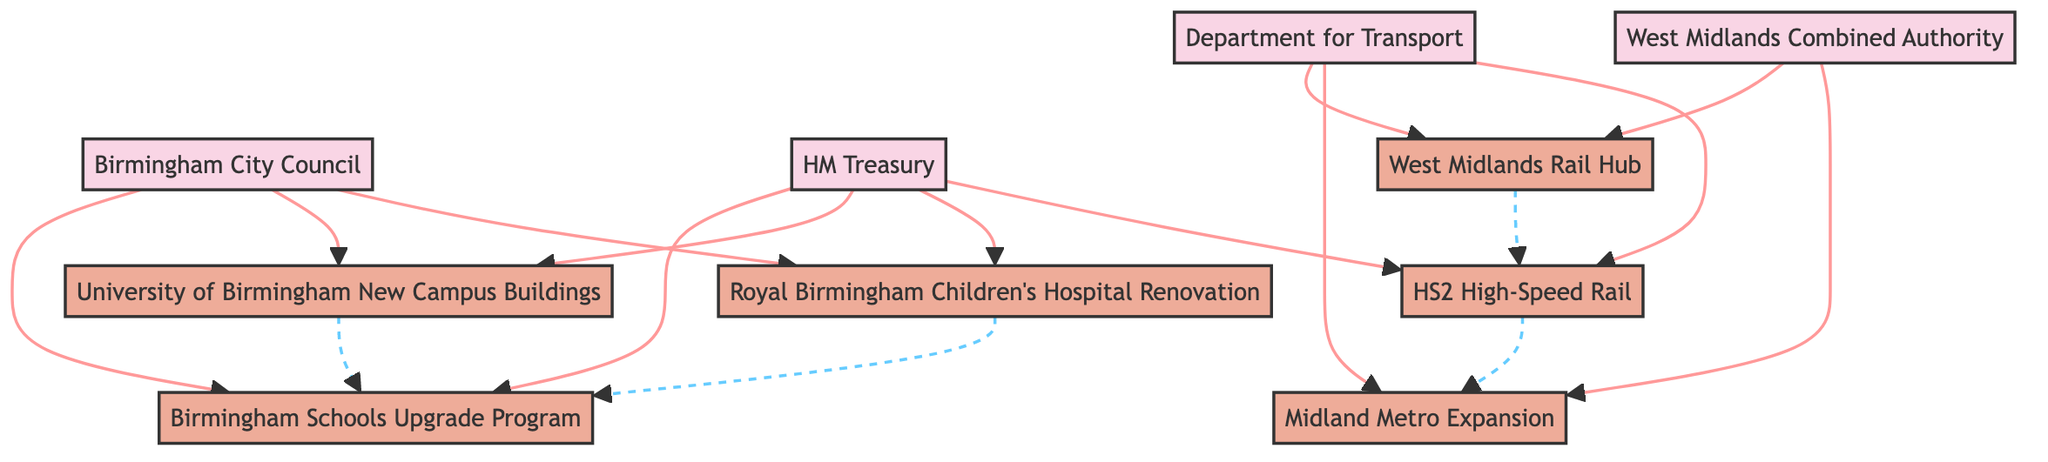What are the transportation projects in the diagram? The diagram lists three transportation projects: HS2 High-Speed Rail, Midland Metro Expansion, and West Midlands Rail Hub. Each of these projects is labeled as a transportation project in the diagram.
Answer: HS2 High-Speed Rail, Midland Metro Expansion, West Midlands Rail Hub How many funding sources are represented? The diagram includes four funding sources: Birmingham City Council, Department for Transport, West Midlands Combined Authority, and HM Treasury. Counting the unique funding sources gives us a total of four.
Answer: 4 What interdependency involves education projects? The interdependency involving education projects is between University of Birmingham New Campus Buildings and Birmingham Schools Upgrade Program. This relationship shows how the improvement in educational infrastructure contributes to skills development.
Answer: University of Birmingham New Campus Buildings and Birmingham Schools Upgrade Program Which project is funded by HM Treasury and Birmingham City Council? Royal Birmingham Children's Hospital Renovation and Birmingham Schools Upgrade Program are both funded by HM Treasury and Birmingham City Council as shown in the funding sources of those projects.
Answer: Royal Birmingham Children's Hospital Renovation, Birmingham Schools Upgrade Program What describes the relationship between HS2 High-Speed Rail and Midland Metro Expansion? The relationship describes an infrastructure interdependency, indicating that the metro expansion is designed to connect with the HS2 stations, improving the overall transportation network.
Answer: Infrastructure Interdependency: Metro expansion to connect with HS2 stations Which funding source is unique to healthcare projects? The funding source unique to healthcare projects, specifically for the Royal Birmingham Children's Hospital Renovation, is Birmingham City Council and HM Treasury, which specifically fund healthcare projects in this context.
Answer: Birmingham City Council, HM Treasury How many education projects are in the diagram? The diagram shows two education projects: University of Birmingham New Campus Buildings and Birmingham Schools Upgrade Program. Counting these identifies a total of two education projects represented.
Answer: 2 Which project is connected to HS2 through a railway hub? The project connected to HS2 through a railway hub is the West Midlands Rail Hub. The diagram illustrates this transportation network interdependency showing the integration of both projects.
Answer: West Midlands Rail Hub 